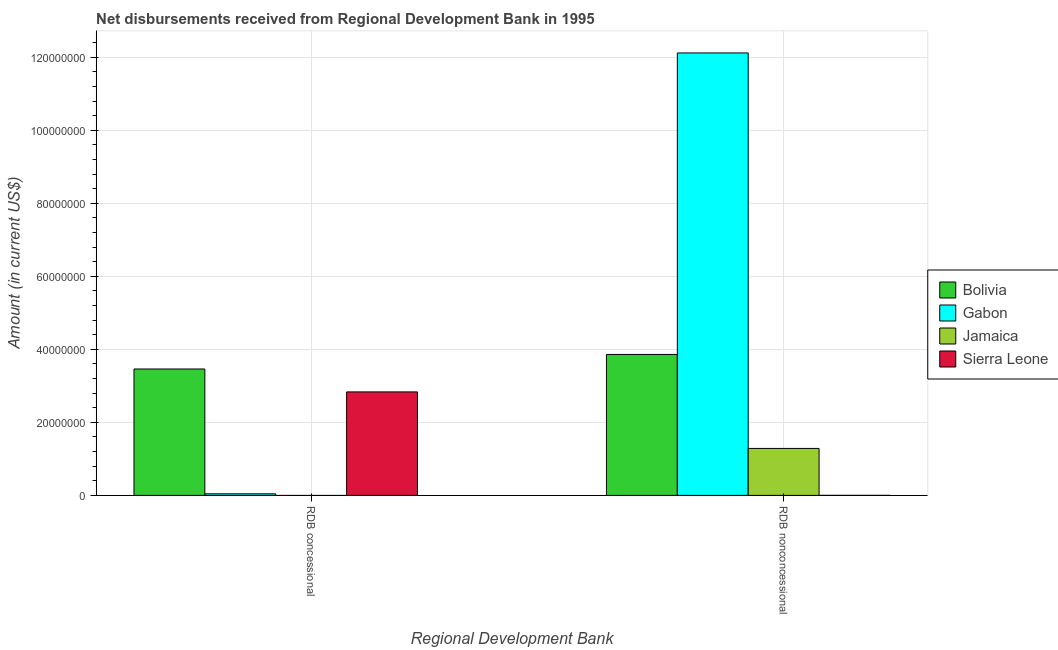How many different coloured bars are there?
Ensure brevity in your answer.  4. How many groups of bars are there?
Provide a succinct answer. 2. Are the number of bars on each tick of the X-axis equal?
Provide a short and direct response. No. How many bars are there on the 1st tick from the left?
Offer a terse response. 3. How many bars are there on the 1st tick from the right?
Your response must be concise. 4. What is the label of the 1st group of bars from the left?
Provide a short and direct response. RDB concessional. What is the net concessional disbursements from rdb in Sierra Leone?
Your response must be concise. 2.83e+07. Across all countries, what is the maximum net concessional disbursements from rdb?
Keep it short and to the point. 3.46e+07. Across all countries, what is the minimum net non concessional disbursements from rdb?
Keep it short and to the point. 6000. In which country was the net non concessional disbursements from rdb maximum?
Provide a succinct answer. Gabon. What is the total net concessional disbursements from rdb in the graph?
Provide a succinct answer. 6.34e+07. What is the difference between the net non concessional disbursements from rdb in Sierra Leone and that in Jamaica?
Provide a succinct answer. -1.29e+07. What is the difference between the net concessional disbursements from rdb in Bolivia and the net non concessional disbursements from rdb in Sierra Leone?
Make the answer very short. 3.46e+07. What is the average net concessional disbursements from rdb per country?
Your response must be concise. 1.59e+07. What is the difference between the net non concessional disbursements from rdb and net concessional disbursements from rdb in Bolivia?
Provide a succinct answer. 3.98e+06. In how many countries, is the net non concessional disbursements from rdb greater than 40000000 US$?
Provide a succinct answer. 1. What is the ratio of the net non concessional disbursements from rdb in Sierra Leone to that in Gabon?
Your answer should be compact. 4.949678270912391e-5. Is the net concessional disbursements from rdb in Bolivia less than that in Gabon?
Your answer should be very brief. No. In how many countries, is the net non concessional disbursements from rdb greater than the average net non concessional disbursements from rdb taken over all countries?
Give a very brief answer. 1. How many bars are there?
Offer a very short reply. 7. How many countries are there in the graph?
Provide a short and direct response. 4. What is the difference between two consecutive major ticks on the Y-axis?
Ensure brevity in your answer.  2.00e+07. Are the values on the major ticks of Y-axis written in scientific E-notation?
Keep it short and to the point. No. Does the graph contain any zero values?
Your answer should be compact. Yes. Does the graph contain grids?
Ensure brevity in your answer.  Yes. What is the title of the graph?
Provide a succinct answer. Net disbursements received from Regional Development Bank in 1995. Does "East Asia (all income levels)" appear as one of the legend labels in the graph?
Make the answer very short. No. What is the label or title of the X-axis?
Ensure brevity in your answer.  Regional Development Bank. What is the Amount (in current US$) of Bolivia in RDB concessional?
Offer a terse response. 3.46e+07. What is the Amount (in current US$) of Gabon in RDB concessional?
Give a very brief answer. 4.31e+05. What is the Amount (in current US$) in Jamaica in RDB concessional?
Your answer should be compact. 0. What is the Amount (in current US$) of Sierra Leone in RDB concessional?
Offer a very short reply. 2.83e+07. What is the Amount (in current US$) in Bolivia in RDB nonconcessional?
Your answer should be compact. 3.86e+07. What is the Amount (in current US$) in Gabon in RDB nonconcessional?
Your answer should be very brief. 1.21e+08. What is the Amount (in current US$) of Jamaica in RDB nonconcessional?
Provide a succinct answer. 1.29e+07. What is the Amount (in current US$) in Sierra Leone in RDB nonconcessional?
Provide a succinct answer. 6000. Across all Regional Development Bank, what is the maximum Amount (in current US$) of Bolivia?
Make the answer very short. 3.86e+07. Across all Regional Development Bank, what is the maximum Amount (in current US$) of Gabon?
Give a very brief answer. 1.21e+08. Across all Regional Development Bank, what is the maximum Amount (in current US$) in Jamaica?
Your answer should be compact. 1.29e+07. Across all Regional Development Bank, what is the maximum Amount (in current US$) in Sierra Leone?
Your response must be concise. 2.83e+07. Across all Regional Development Bank, what is the minimum Amount (in current US$) in Bolivia?
Your answer should be compact. 3.46e+07. Across all Regional Development Bank, what is the minimum Amount (in current US$) in Gabon?
Give a very brief answer. 4.31e+05. Across all Regional Development Bank, what is the minimum Amount (in current US$) in Jamaica?
Make the answer very short. 0. Across all Regional Development Bank, what is the minimum Amount (in current US$) of Sierra Leone?
Offer a terse response. 6000. What is the total Amount (in current US$) of Bolivia in the graph?
Give a very brief answer. 7.32e+07. What is the total Amount (in current US$) of Gabon in the graph?
Your response must be concise. 1.22e+08. What is the total Amount (in current US$) in Jamaica in the graph?
Ensure brevity in your answer.  1.29e+07. What is the total Amount (in current US$) in Sierra Leone in the graph?
Keep it short and to the point. 2.84e+07. What is the difference between the Amount (in current US$) in Bolivia in RDB concessional and that in RDB nonconcessional?
Your answer should be compact. -3.98e+06. What is the difference between the Amount (in current US$) of Gabon in RDB concessional and that in RDB nonconcessional?
Provide a short and direct response. -1.21e+08. What is the difference between the Amount (in current US$) of Sierra Leone in RDB concessional and that in RDB nonconcessional?
Provide a short and direct response. 2.83e+07. What is the difference between the Amount (in current US$) of Bolivia in RDB concessional and the Amount (in current US$) of Gabon in RDB nonconcessional?
Offer a terse response. -8.66e+07. What is the difference between the Amount (in current US$) in Bolivia in RDB concessional and the Amount (in current US$) in Jamaica in RDB nonconcessional?
Keep it short and to the point. 2.18e+07. What is the difference between the Amount (in current US$) of Bolivia in RDB concessional and the Amount (in current US$) of Sierra Leone in RDB nonconcessional?
Provide a succinct answer. 3.46e+07. What is the difference between the Amount (in current US$) of Gabon in RDB concessional and the Amount (in current US$) of Jamaica in RDB nonconcessional?
Your answer should be compact. -1.24e+07. What is the difference between the Amount (in current US$) of Gabon in RDB concessional and the Amount (in current US$) of Sierra Leone in RDB nonconcessional?
Provide a succinct answer. 4.25e+05. What is the average Amount (in current US$) of Bolivia per Regional Development Bank?
Give a very brief answer. 3.66e+07. What is the average Amount (in current US$) of Gabon per Regional Development Bank?
Provide a short and direct response. 6.08e+07. What is the average Amount (in current US$) of Jamaica per Regional Development Bank?
Provide a short and direct response. 6.43e+06. What is the average Amount (in current US$) of Sierra Leone per Regional Development Bank?
Offer a terse response. 1.42e+07. What is the difference between the Amount (in current US$) of Bolivia and Amount (in current US$) of Gabon in RDB concessional?
Offer a very short reply. 3.42e+07. What is the difference between the Amount (in current US$) in Bolivia and Amount (in current US$) in Sierra Leone in RDB concessional?
Ensure brevity in your answer.  6.28e+06. What is the difference between the Amount (in current US$) in Gabon and Amount (in current US$) in Sierra Leone in RDB concessional?
Provide a succinct answer. -2.79e+07. What is the difference between the Amount (in current US$) of Bolivia and Amount (in current US$) of Gabon in RDB nonconcessional?
Make the answer very short. -8.26e+07. What is the difference between the Amount (in current US$) in Bolivia and Amount (in current US$) in Jamaica in RDB nonconcessional?
Make the answer very short. 2.57e+07. What is the difference between the Amount (in current US$) of Bolivia and Amount (in current US$) of Sierra Leone in RDB nonconcessional?
Offer a terse response. 3.86e+07. What is the difference between the Amount (in current US$) of Gabon and Amount (in current US$) of Jamaica in RDB nonconcessional?
Give a very brief answer. 1.08e+08. What is the difference between the Amount (in current US$) of Gabon and Amount (in current US$) of Sierra Leone in RDB nonconcessional?
Ensure brevity in your answer.  1.21e+08. What is the difference between the Amount (in current US$) of Jamaica and Amount (in current US$) of Sierra Leone in RDB nonconcessional?
Offer a terse response. 1.29e+07. What is the ratio of the Amount (in current US$) in Bolivia in RDB concessional to that in RDB nonconcessional?
Provide a succinct answer. 0.9. What is the ratio of the Amount (in current US$) in Gabon in RDB concessional to that in RDB nonconcessional?
Give a very brief answer. 0. What is the ratio of the Amount (in current US$) in Sierra Leone in RDB concessional to that in RDB nonconcessional?
Keep it short and to the point. 4724.83. What is the difference between the highest and the second highest Amount (in current US$) of Bolivia?
Make the answer very short. 3.98e+06. What is the difference between the highest and the second highest Amount (in current US$) of Gabon?
Your response must be concise. 1.21e+08. What is the difference between the highest and the second highest Amount (in current US$) of Sierra Leone?
Give a very brief answer. 2.83e+07. What is the difference between the highest and the lowest Amount (in current US$) of Bolivia?
Your answer should be compact. 3.98e+06. What is the difference between the highest and the lowest Amount (in current US$) of Gabon?
Give a very brief answer. 1.21e+08. What is the difference between the highest and the lowest Amount (in current US$) in Jamaica?
Provide a succinct answer. 1.29e+07. What is the difference between the highest and the lowest Amount (in current US$) in Sierra Leone?
Keep it short and to the point. 2.83e+07. 